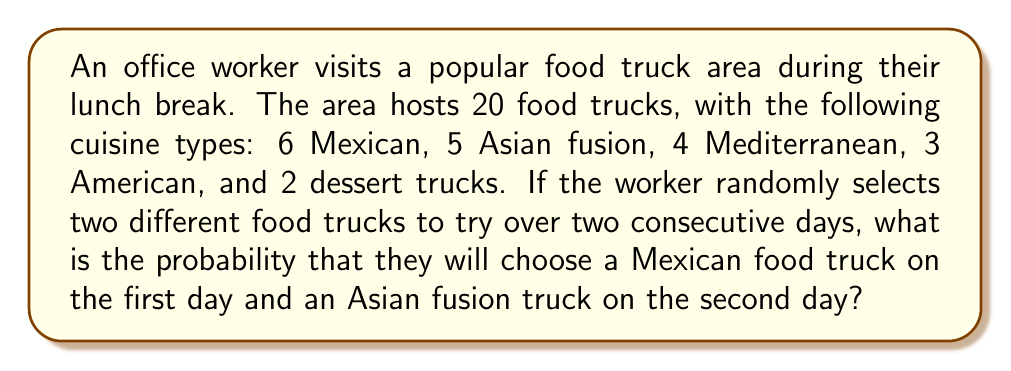Solve this math problem. Let's approach this step-by-step using the principles of probability:

1) First, we need to calculate the probability of choosing a Mexican food truck on the first day:
   $$P(\text{Mexican on day 1}) = \frac{6}{20} = \frac{3}{10}$$

2) For the second day, we need to calculate the probability of choosing an Asian fusion truck, given that a Mexican truck was chosen on the first day:
   $$P(\text{Asian fusion on day 2 | Mexican on day 1}) = \frac{5}{19}$$
   Note that there are only 19 trucks left to choose from on the second day.

3) The probability of both events occurring is the product of their individual probabilities:
   $$P(\text{Mexican on day 1 AND Asian fusion on day 2}) = P(\text{Mexican on day 1}) \times P(\text{Asian fusion on day 2 | Mexican on day 1})$$

4) Substituting the values:
   $$P(\text{Mexican on day 1 AND Asian fusion on day 2}) = \frac{3}{10} \times \frac{5}{19}$$

5) Simplifying:
   $$P(\text{Mexican on day 1 AND Asian fusion on day 2}) = \frac{3 \times 5}{10 \times 19} = \frac{15}{190} = \frac{3}{38}$$

Therefore, the probability of choosing a Mexican food truck on the first day and an Asian fusion truck on the second day is $\frac{3}{38}$.
Answer: $\frac{3}{38}$ or approximately 0.0789 or 7.89% 